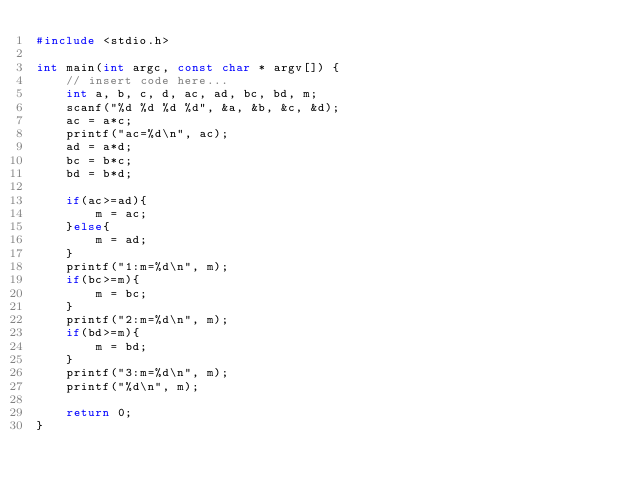<code> <loc_0><loc_0><loc_500><loc_500><_C_>#include <stdio.h>
 
int main(int argc, const char * argv[]) {
    // insert code here...
    int a, b, c, d, ac, ad, bc, bd, m;
    scanf("%d %d %d %d", &a, &b, &c, &d);
    ac = a*c;
    printf("ac=%d\n", ac);
    ad = a*d;
    bc = b*c;
    bd = b*d;
    
    if(ac>=ad){
        m = ac;
    }else{
        m = ad;
    }
    printf("1:m=%d\n", m);
    if(bc>=m){
        m = bc;
    }
    printf("2:m=%d\n", m);
    if(bd>=m){
        m = bd;
    }
    printf("3:m=%d\n", m);
    printf("%d\n", m);
    
    return 0;
}</code> 